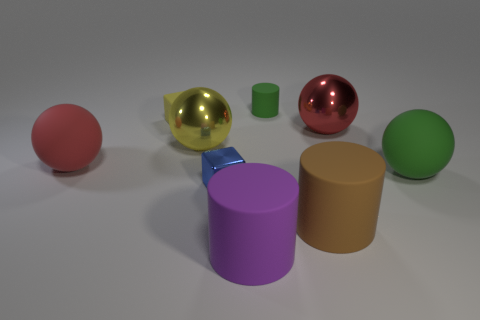Subtract all large cylinders. How many cylinders are left? 1 Subtract all yellow spheres. How many spheres are left? 3 Subtract all spheres. How many objects are left? 5 Subtract all brown balls. Subtract all blue cubes. How many balls are left? 4 Subtract all big red balls. Subtract all yellow objects. How many objects are left? 5 Add 8 large brown rubber cylinders. How many large brown rubber cylinders are left? 9 Add 3 tiny blue matte spheres. How many tiny blue matte spheres exist? 3 Subtract 0 gray cylinders. How many objects are left? 9 